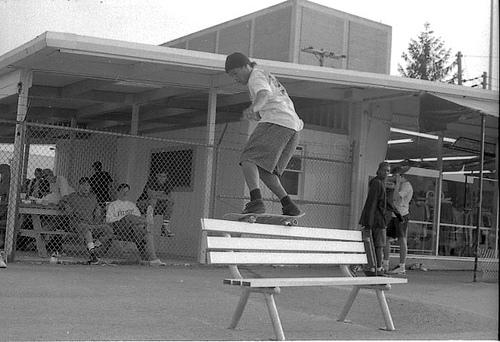What is the skateboard above?
Concise answer only. Bench. What is the kid on the skateboard doing?
Concise answer only. Skating on bench. Is the image in black and white?
Keep it brief. Yes. 